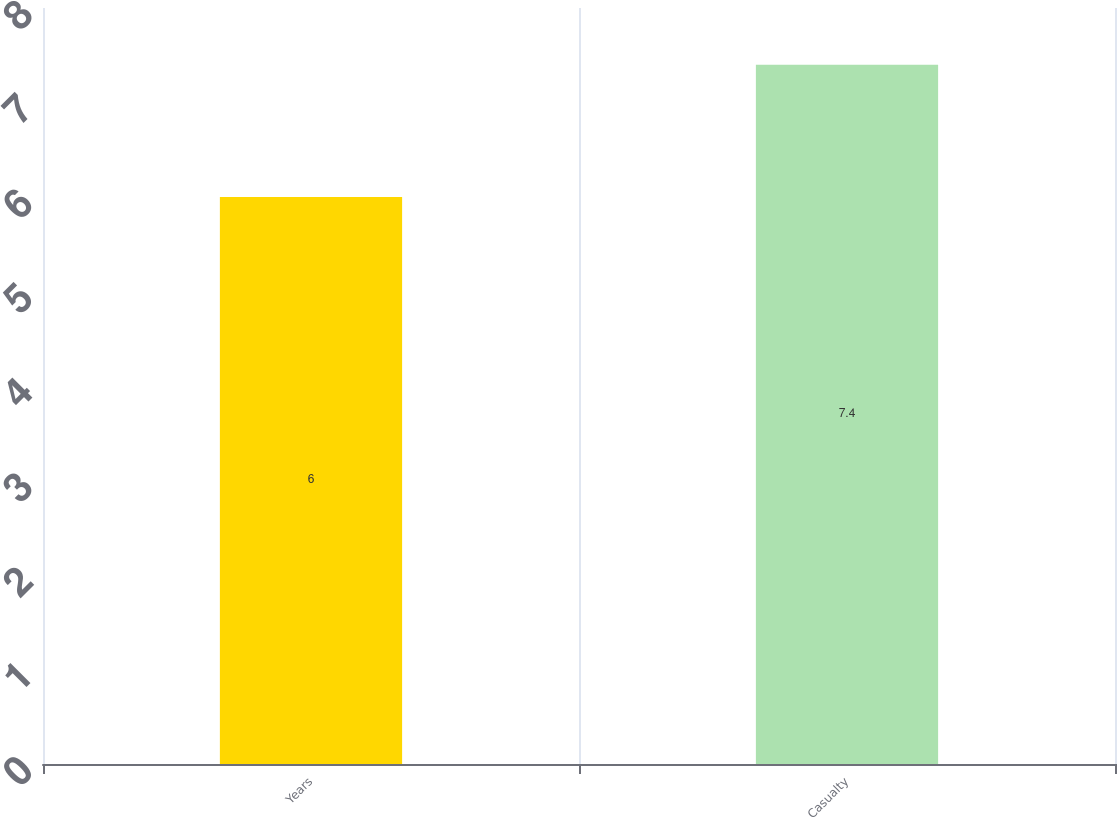Convert chart. <chart><loc_0><loc_0><loc_500><loc_500><bar_chart><fcel>Years<fcel>Casualty<nl><fcel>6<fcel>7.4<nl></chart> 